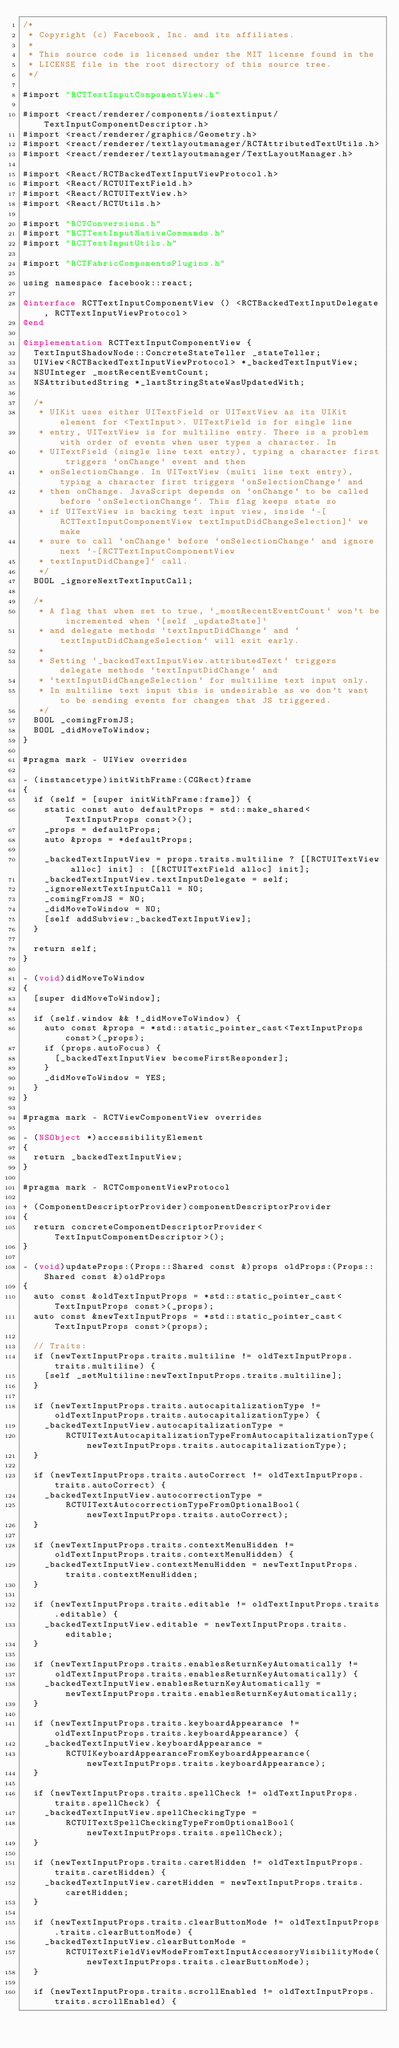<code> <loc_0><loc_0><loc_500><loc_500><_ObjectiveC_>/*
 * Copyright (c) Facebook, Inc. and its affiliates.
 *
 * This source code is licensed under the MIT license found in the
 * LICENSE file in the root directory of this source tree.
 */

#import "RCTTextInputComponentView.h"

#import <react/renderer/components/iostextinput/TextInputComponentDescriptor.h>
#import <react/renderer/graphics/Geometry.h>
#import <react/renderer/textlayoutmanager/RCTAttributedTextUtils.h>
#import <react/renderer/textlayoutmanager/TextLayoutManager.h>

#import <React/RCTBackedTextInputViewProtocol.h>
#import <React/RCTUITextField.h>
#import <React/RCTUITextView.h>
#import <React/RCTUtils.h>

#import "RCTConversions.h"
#import "RCTTextInputNativeCommands.h"
#import "RCTTextInputUtils.h"

#import "RCTFabricComponentsPlugins.h"

using namespace facebook::react;

@interface RCTTextInputComponentView () <RCTBackedTextInputDelegate, RCTTextInputViewProtocol>
@end

@implementation RCTTextInputComponentView {
  TextInputShadowNode::ConcreteStateTeller _stateTeller;
  UIView<RCTBackedTextInputViewProtocol> *_backedTextInputView;
  NSUInteger _mostRecentEventCount;
  NSAttributedString *_lastStringStateWasUpdatedWith;

  /*
   * UIKit uses either UITextField or UITextView as its UIKit element for <TextInput>. UITextField is for single line
   * entry, UITextView is for multiline entry. There is a problem with order of events when user types a character. In
   * UITextField (single line text entry), typing a character first triggers `onChange` event and then
   * onSelectionChange. In UITextView (multi line text entry), typing a character first triggers `onSelectionChange` and
   * then onChange. JavaScript depends on `onChange` to be called before `onSelectionChange`. This flag keeps state so
   * if UITextView is backing text input view, inside `-[RCTTextInputComponentView textInputDidChangeSelection]` we make
   * sure to call `onChange` before `onSelectionChange` and ignore next `-[RCTTextInputComponentView
   * textInputDidChange]` call.
   */
  BOOL _ignoreNextTextInputCall;

  /*
   * A flag that when set to true, `_mostRecentEventCount` won't be incremented when `[self _updateState]`
   * and delegate methods `textInputDidChange` and `textInputDidChangeSelection` will exit early.
   *
   * Setting `_backedTextInputView.attributedText` triggers delegate methods `textInputDidChange` and
   * `textInputDidChangeSelection` for multiline text input only.
   * In multiline text input this is undesirable as we don't want to be sending events for changes that JS triggered.
   */
  BOOL _comingFromJS;
  BOOL _didMoveToWindow;
}

#pragma mark - UIView overrides

- (instancetype)initWithFrame:(CGRect)frame
{
  if (self = [super initWithFrame:frame]) {
    static const auto defaultProps = std::make_shared<TextInputProps const>();
    _props = defaultProps;
    auto &props = *defaultProps;

    _backedTextInputView = props.traits.multiline ? [[RCTUITextView alloc] init] : [[RCTUITextField alloc] init];
    _backedTextInputView.textInputDelegate = self;
    _ignoreNextTextInputCall = NO;
    _comingFromJS = NO;
    _didMoveToWindow = NO;
    [self addSubview:_backedTextInputView];
  }

  return self;
}

- (void)didMoveToWindow
{
  [super didMoveToWindow];

  if (self.window && !_didMoveToWindow) {
    auto const &props = *std::static_pointer_cast<TextInputProps const>(_props);
    if (props.autoFocus) {
      [_backedTextInputView becomeFirstResponder];
    }
    _didMoveToWindow = YES;
  }
}

#pragma mark - RCTViewComponentView overrides

- (NSObject *)accessibilityElement
{
  return _backedTextInputView;
}

#pragma mark - RCTComponentViewProtocol

+ (ComponentDescriptorProvider)componentDescriptorProvider
{
  return concreteComponentDescriptorProvider<TextInputComponentDescriptor>();
}

- (void)updateProps:(Props::Shared const &)props oldProps:(Props::Shared const &)oldProps
{
  auto const &oldTextInputProps = *std::static_pointer_cast<TextInputProps const>(_props);
  auto const &newTextInputProps = *std::static_pointer_cast<TextInputProps const>(props);

  // Traits:
  if (newTextInputProps.traits.multiline != oldTextInputProps.traits.multiline) {
    [self _setMultiline:newTextInputProps.traits.multiline];
  }

  if (newTextInputProps.traits.autocapitalizationType != oldTextInputProps.traits.autocapitalizationType) {
    _backedTextInputView.autocapitalizationType =
        RCTUITextAutocapitalizationTypeFromAutocapitalizationType(newTextInputProps.traits.autocapitalizationType);
  }

  if (newTextInputProps.traits.autoCorrect != oldTextInputProps.traits.autoCorrect) {
    _backedTextInputView.autocorrectionType =
        RCTUITextAutocorrectionTypeFromOptionalBool(newTextInputProps.traits.autoCorrect);
  }

  if (newTextInputProps.traits.contextMenuHidden != oldTextInputProps.traits.contextMenuHidden) {
    _backedTextInputView.contextMenuHidden = newTextInputProps.traits.contextMenuHidden;
  }

  if (newTextInputProps.traits.editable != oldTextInputProps.traits.editable) {
    _backedTextInputView.editable = newTextInputProps.traits.editable;
  }

  if (newTextInputProps.traits.enablesReturnKeyAutomatically !=
      oldTextInputProps.traits.enablesReturnKeyAutomatically) {
    _backedTextInputView.enablesReturnKeyAutomatically = newTextInputProps.traits.enablesReturnKeyAutomatically;
  }

  if (newTextInputProps.traits.keyboardAppearance != oldTextInputProps.traits.keyboardAppearance) {
    _backedTextInputView.keyboardAppearance =
        RCTUIKeyboardAppearanceFromKeyboardAppearance(newTextInputProps.traits.keyboardAppearance);
  }

  if (newTextInputProps.traits.spellCheck != oldTextInputProps.traits.spellCheck) {
    _backedTextInputView.spellCheckingType =
        RCTUITextSpellCheckingTypeFromOptionalBool(newTextInputProps.traits.spellCheck);
  }

  if (newTextInputProps.traits.caretHidden != oldTextInputProps.traits.caretHidden) {
    _backedTextInputView.caretHidden = newTextInputProps.traits.caretHidden;
  }

  if (newTextInputProps.traits.clearButtonMode != oldTextInputProps.traits.clearButtonMode) {
    _backedTextInputView.clearButtonMode =
        RCTUITextFieldViewModeFromTextInputAccessoryVisibilityMode(newTextInputProps.traits.clearButtonMode);
  }

  if (newTextInputProps.traits.scrollEnabled != oldTextInputProps.traits.scrollEnabled) {</code> 